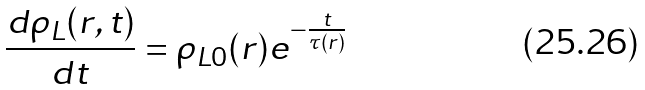<formula> <loc_0><loc_0><loc_500><loc_500>\frac { d { \rho _ { L } } ( r , t ) } { d t } = \rho _ { L 0 } ( r ) e ^ { - \frac { t } { \tau ( r ) } }</formula> 